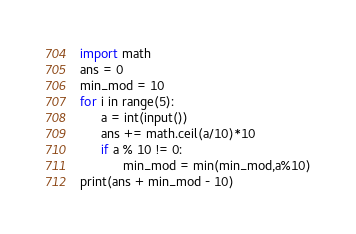<code> <loc_0><loc_0><loc_500><loc_500><_Python_>import math
ans = 0
min_mod = 10
for i in range(5):
      a = int(input())
      ans += math.ceil(a/10)*10
      if a % 10 != 0:
            min_mod = min(min_mod,a%10)
print(ans + min_mod - 10)</code> 